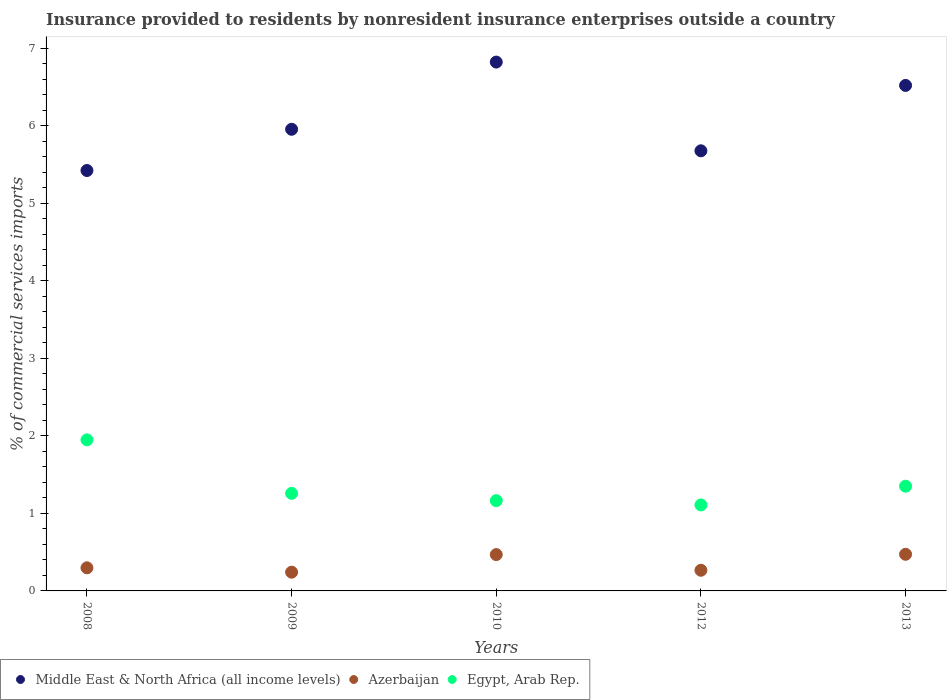Is the number of dotlines equal to the number of legend labels?
Make the answer very short. Yes. What is the Insurance provided to residents in Egypt, Arab Rep. in 2010?
Provide a succinct answer. 1.16. Across all years, what is the maximum Insurance provided to residents in Middle East & North Africa (all income levels)?
Provide a short and direct response. 6.82. Across all years, what is the minimum Insurance provided to residents in Middle East & North Africa (all income levels)?
Your response must be concise. 5.42. What is the total Insurance provided to residents in Middle East & North Africa (all income levels) in the graph?
Offer a very short reply. 30.39. What is the difference between the Insurance provided to residents in Egypt, Arab Rep. in 2009 and that in 2013?
Ensure brevity in your answer.  -0.09. What is the difference between the Insurance provided to residents in Azerbaijan in 2013 and the Insurance provided to residents in Middle East & North Africa (all income levels) in 2012?
Make the answer very short. -5.2. What is the average Insurance provided to residents in Middle East & North Africa (all income levels) per year?
Provide a succinct answer. 6.08. In the year 2012, what is the difference between the Insurance provided to residents in Middle East & North Africa (all income levels) and Insurance provided to residents in Egypt, Arab Rep.?
Provide a succinct answer. 4.57. What is the ratio of the Insurance provided to residents in Middle East & North Africa (all income levels) in 2010 to that in 2013?
Provide a succinct answer. 1.05. What is the difference between the highest and the second highest Insurance provided to residents in Azerbaijan?
Your response must be concise. 0. What is the difference between the highest and the lowest Insurance provided to residents in Middle East & North Africa (all income levels)?
Provide a succinct answer. 1.4. Is the sum of the Insurance provided to residents in Azerbaijan in 2010 and 2013 greater than the maximum Insurance provided to residents in Middle East & North Africa (all income levels) across all years?
Offer a terse response. No. Is it the case that in every year, the sum of the Insurance provided to residents in Azerbaijan and Insurance provided to residents in Egypt, Arab Rep.  is greater than the Insurance provided to residents in Middle East & North Africa (all income levels)?
Offer a very short reply. No. Does the Insurance provided to residents in Egypt, Arab Rep. monotonically increase over the years?
Ensure brevity in your answer.  No. How many dotlines are there?
Ensure brevity in your answer.  3. What is the difference between two consecutive major ticks on the Y-axis?
Your answer should be very brief. 1. Does the graph contain grids?
Keep it short and to the point. No. How are the legend labels stacked?
Your response must be concise. Horizontal. What is the title of the graph?
Your answer should be compact. Insurance provided to residents by nonresident insurance enterprises outside a country. What is the label or title of the X-axis?
Give a very brief answer. Years. What is the label or title of the Y-axis?
Offer a terse response. % of commercial services imports. What is the % of commercial services imports of Middle East & North Africa (all income levels) in 2008?
Your answer should be very brief. 5.42. What is the % of commercial services imports in Azerbaijan in 2008?
Keep it short and to the point. 0.3. What is the % of commercial services imports of Egypt, Arab Rep. in 2008?
Make the answer very short. 1.95. What is the % of commercial services imports in Middle East & North Africa (all income levels) in 2009?
Your answer should be very brief. 5.95. What is the % of commercial services imports of Azerbaijan in 2009?
Offer a terse response. 0.24. What is the % of commercial services imports in Egypt, Arab Rep. in 2009?
Provide a short and direct response. 1.26. What is the % of commercial services imports of Middle East & North Africa (all income levels) in 2010?
Your answer should be compact. 6.82. What is the % of commercial services imports in Azerbaijan in 2010?
Offer a very short reply. 0.47. What is the % of commercial services imports of Egypt, Arab Rep. in 2010?
Provide a succinct answer. 1.16. What is the % of commercial services imports in Middle East & North Africa (all income levels) in 2012?
Offer a very short reply. 5.68. What is the % of commercial services imports in Azerbaijan in 2012?
Provide a short and direct response. 0.27. What is the % of commercial services imports in Egypt, Arab Rep. in 2012?
Provide a short and direct response. 1.11. What is the % of commercial services imports in Middle East & North Africa (all income levels) in 2013?
Your response must be concise. 6.52. What is the % of commercial services imports of Azerbaijan in 2013?
Your response must be concise. 0.47. What is the % of commercial services imports of Egypt, Arab Rep. in 2013?
Make the answer very short. 1.35. Across all years, what is the maximum % of commercial services imports in Middle East & North Africa (all income levels)?
Your response must be concise. 6.82. Across all years, what is the maximum % of commercial services imports in Azerbaijan?
Offer a very short reply. 0.47. Across all years, what is the maximum % of commercial services imports in Egypt, Arab Rep.?
Your answer should be compact. 1.95. Across all years, what is the minimum % of commercial services imports of Middle East & North Africa (all income levels)?
Your answer should be compact. 5.42. Across all years, what is the minimum % of commercial services imports in Azerbaijan?
Your answer should be very brief. 0.24. Across all years, what is the minimum % of commercial services imports of Egypt, Arab Rep.?
Make the answer very short. 1.11. What is the total % of commercial services imports of Middle East & North Africa (all income levels) in the graph?
Give a very brief answer. 30.39. What is the total % of commercial services imports in Azerbaijan in the graph?
Give a very brief answer. 1.75. What is the total % of commercial services imports in Egypt, Arab Rep. in the graph?
Make the answer very short. 6.83. What is the difference between the % of commercial services imports of Middle East & North Africa (all income levels) in 2008 and that in 2009?
Provide a succinct answer. -0.53. What is the difference between the % of commercial services imports of Azerbaijan in 2008 and that in 2009?
Your response must be concise. 0.06. What is the difference between the % of commercial services imports of Egypt, Arab Rep. in 2008 and that in 2009?
Offer a terse response. 0.69. What is the difference between the % of commercial services imports of Middle East & North Africa (all income levels) in 2008 and that in 2010?
Your answer should be very brief. -1.4. What is the difference between the % of commercial services imports in Azerbaijan in 2008 and that in 2010?
Offer a very short reply. -0.17. What is the difference between the % of commercial services imports of Egypt, Arab Rep. in 2008 and that in 2010?
Your answer should be very brief. 0.78. What is the difference between the % of commercial services imports of Middle East & North Africa (all income levels) in 2008 and that in 2012?
Provide a succinct answer. -0.25. What is the difference between the % of commercial services imports in Azerbaijan in 2008 and that in 2012?
Your answer should be very brief. 0.03. What is the difference between the % of commercial services imports of Egypt, Arab Rep. in 2008 and that in 2012?
Your answer should be compact. 0.84. What is the difference between the % of commercial services imports of Middle East & North Africa (all income levels) in 2008 and that in 2013?
Make the answer very short. -1.1. What is the difference between the % of commercial services imports in Azerbaijan in 2008 and that in 2013?
Ensure brevity in your answer.  -0.17. What is the difference between the % of commercial services imports of Egypt, Arab Rep. in 2008 and that in 2013?
Keep it short and to the point. 0.6. What is the difference between the % of commercial services imports in Middle East & North Africa (all income levels) in 2009 and that in 2010?
Your answer should be compact. -0.87. What is the difference between the % of commercial services imports in Azerbaijan in 2009 and that in 2010?
Your answer should be very brief. -0.23. What is the difference between the % of commercial services imports in Egypt, Arab Rep. in 2009 and that in 2010?
Give a very brief answer. 0.09. What is the difference between the % of commercial services imports in Middle East & North Africa (all income levels) in 2009 and that in 2012?
Your response must be concise. 0.28. What is the difference between the % of commercial services imports of Azerbaijan in 2009 and that in 2012?
Your response must be concise. -0.02. What is the difference between the % of commercial services imports in Egypt, Arab Rep. in 2009 and that in 2012?
Provide a succinct answer. 0.15. What is the difference between the % of commercial services imports of Middle East & North Africa (all income levels) in 2009 and that in 2013?
Make the answer very short. -0.57. What is the difference between the % of commercial services imports of Azerbaijan in 2009 and that in 2013?
Offer a terse response. -0.23. What is the difference between the % of commercial services imports in Egypt, Arab Rep. in 2009 and that in 2013?
Make the answer very short. -0.09. What is the difference between the % of commercial services imports in Middle East & North Africa (all income levels) in 2010 and that in 2012?
Ensure brevity in your answer.  1.14. What is the difference between the % of commercial services imports of Azerbaijan in 2010 and that in 2012?
Ensure brevity in your answer.  0.2. What is the difference between the % of commercial services imports of Egypt, Arab Rep. in 2010 and that in 2012?
Make the answer very short. 0.06. What is the difference between the % of commercial services imports in Middle East & North Africa (all income levels) in 2010 and that in 2013?
Provide a succinct answer. 0.3. What is the difference between the % of commercial services imports of Azerbaijan in 2010 and that in 2013?
Your response must be concise. -0. What is the difference between the % of commercial services imports of Egypt, Arab Rep. in 2010 and that in 2013?
Offer a very short reply. -0.19. What is the difference between the % of commercial services imports in Middle East & North Africa (all income levels) in 2012 and that in 2013?
Ensure brevity in your answer.  -0.84. What is the difference between the % of commercial services imports of Azerbaijan in 2012 and that in 2013?
Your response must be concise. -0.21. What is the difference between the % of commercial services imports in Egypt, Arab Rep. in 2012 and that in 2013?
Offer a terse response. -0.24. What is the difference between the % of commercial services imports in Middle East & North Africa (all income levels) in 2008 and the % of commercial services imports in Azerbaijan in 2009?
Offer a very short reply. 5.18. What is the difference between the % of commercial services imports of Middle East & North Africa (all income levels) in 2008 and the % of commercial services imports of Egypt, Arab Rep. in 2009?
Make the answer very short. 4.16. What is the difference between the % of commercial services imports in Azerbaijan in 2008 and the % of commercial services imports in Egypt, Arab Rep. in 2009?
Offer a terse response. -0.96. What is the difference between the % of commercial services imports in Middle East & North Africa (all income levels) in 2008 and the % of commercial services imports in Azerbaijan in 2010?
Your answer should be very brief. 4.95. What is the difference between the % of commercial services imports in Middle East & North Africa (all income levels) in 2008 and the % of commercial services imports in Egypt, Arab Rep. in 2010?
Provide a short and direct response. 4.26. What is the difference between the % of commercial services imports of Azerbaijan in 2008 and the % of commercial services imports of Egypt, Arab Rep. in 2010?
Your answer should be very brief. -0.87. What is the difference between the % of commercial services imports of Middle East & North Africa (all income levels) in 2008 and the % of commercial services imports of Azerbaijan in 2012?
Offer a very short reply. 5.15. What is the difference between the % of commercial services imports of Middle East & North Africa (all income levels) in 2008 and the % of commercial services imports of Egypt, Arab Rep. in 2012?
Offer a terse response. 4.31. What is the difference between the % of commercial services imports in Azerbaijan in 2008 and the % of commercial services imports in Egypt, Arab Rep. in 2012?
Give a very brief answer. -0.81. What is the difference between the % of commercial services imports of Middle East & North Africa (all income levels) in 2008 and the % of commercial services imports of Azerbaijan in 2013?
Give a very brief answer. 4.95. What is the difference between the % of commercial services imports in Middle East & North Africa (all income levels) in 2008 and the % of commercial services imports in Egypt, Arab Rep. in 2013?
Ensure brevity in your answer.  4.07. What is the difference between the % of commercial services imports of Azerbaijan in 2008 and the % of commercial services imports of Egypt, Arab Rep. in 2013?
Offer a terse response. -1.05. What is the difference between the % of commercial services imports in Middle East & North Africa (all income levels) in 2009 and the % of commercial services imports in Azerbaijan in 2010?
Ensure brevity in your answer.  5.48. What is the difference between the % of commercial services imports of Middle East & North Africa (all income levels) in 2009 and the % of commercial services imports of Egypt, Arab Rep. in 2010?
Ensure brevity in your answer.  4.79. What is the difference between the % of commercial services imports in Azerbaijan in 2009 and the % of commercial services imports in Egypt, Arab Rep. in 2010?
Ensure brevity in your answer.  -0.92. What is the difference between the % of commercial services imports of Middle East & North Africa (all income levels) in 2009 and the % of commercial services imports of Azerbaijan in 2012?
Offer a terse response. 5.69. What is the difference between the % of commercial services imports in Middle East & North Africa (all income levels) in 2009 and the % of commercial services imports in Egypt, Arab Rep. in 2012?
Offer a very short reply. 4.84. What is the difference between the % of commercial services imports in Azerbaijan in 2009 and the % of commercial services imports in Egypt, Arab Rep. in 2012?
Make the answer very short. -0.87. What is the difference between the % of commercial services imports of Middle East & North Africa (all income levels) in 2009 and the % of commercial services imports of Azerbaijan in 2013?
Give a very brief answer. 5.48. What is the difference between the % of commercial services imports in Middle East & North Africa (all income levels) in 2009 and the % of commercial services imports in Egypt, Arab Rep. in 2013?
Provide a short and direct response. 4.6. What is the difference between the % of commercial services imports of Azerbaijan in 2009 and the % of commercial services imports of Egypt, Arab Rep. in 2013?
Your response must be concise. -1.11. What is the difference between the % of commercial services imports of Middle East & North Africa (all income levels) in 2010 and the % of commercial services imports of Azerbaijan in 2012?
Provide a short and direct response. 6.55. What is the difference between the % of commercial services imports in Middle East & North Africa (all income levels) in 2010 and the % of commercial services imports in Egypt, Arab Rep. in 2012?
Provide a short and direct response. 5.71. What is the difference between the % of commercial services imports of Azerbaijan in 2010 and the % of commercial services imports of Egypt, Arab Rep. in 2012?
Provide a short and direct response. -0.64. What is the difference between the % of commercial services imports in Middle East & North Africa (all income levels) in 2010 and the % of commercial services imports in Azerbaijan in 2013?
Offer a terse response. 6.35. What is the difference between the % of commercial services imports in Middle East & North Africa (all income levels) in 2010 and the % of commercial services imports in Egypt, Arab Rep. in 2013?
Offer a very short reply. 5.47. What is the difference between the % of commercial services imports of Azerbaijan in 2010 and the % of commercial services imports of Egypt, Arab Rep. in 2013?
Ensure brevity in your answer.  -0.88. What is the difference between the % of commercial services imports in Middle East & North Africa (all income levels) in 2012 and the % of commercial services imports in Azerbaijan in 2013?
Your answer should be very brief. 5.2. What is the difference between the % of commercial services imports in Middle East & North Africa (all income levels) in 2012 and the % of commercial services imports in Egypt, Arab Rep. in 2013?
Keep it short and to the point. 4.32. What is the difference between the % of commercial services imports of Azerbaijan in 2012 and the % of commercial services imports of Egypt, Arab Rep. in 2013?
Your response must be concise. -1.08. What is the average % of commercial services imports in Middle East & North Africa (all income levels) per year?
Your response must be concise. 6.08. What is the average % of commercial services imports in Azerbaijan per year?
Your answer should be compact. 0.35. What is the average % of commercial services imports in Egypt, Arab Rep. per year?
Provide a short and direct response. 1.37. In the year 2008, what is the difference between the % of commercial services imports in Middle East & North Africa (all income levels) and % of commercial services imports in Azerbaijan?
Provide a short and direct response. 5.12. In the year 2008, what is the difference between the % of commercial services imports in Middle East & North Africa (all income levels) and % of commercial services imports in Egypt, Arab Rep.?
Keep it short and to the point. 3.47. In the year 2008, what is the difference between the % of commercial services imports of Azerbaijan and % of commercial services imports of Egypt, Arab Rep.?
Your response must be concise. -1.65. In the year 2009, what is the difference between the % of commercial services imports of Middle East & North Africa (all income levels) and % of commercial services imports of Azerbaijan?
Your response must be concise. 5.71. In the year 2009, what is the difference between the % of commercial services imports of Middle East & North Africa (all income levels) and % of commercial services imports of Egypt, Arab Rep.?
Give a very brief answer. 4.69. In the year 2009, what is the difference between the % of commercial services imports in Azerbaijan and % of commercial services imports in Egypt, Arab Rep.?
Offer a terse response. -1.02. In the year 2010, what is the difference between the % of commercial services imports in Middle East & North Africa (all income levels) and % of commercial services imports in Azerbaijan?
Provide a succinct answer. 6.35. In the year 2010, what is the difference between the % of commercial services imports of Middle East & North Africa (all income levels) and % of commercial services imports of Egypt, Arab Rep.?
Your answer should be compact. 5.66. In the year 2010, what is the difference between the % of commercial services imports in Azerbaijan and % of commercial services imports in Egypt, Arab Rep.?
Offer a very short reply. -0.7. In the year 2012, what is the difference between the % of commercial services imports in Middle East & North Africa (all income levels) and % of commercial services imports in Azerbaijan?
Your answer should be very brief. 5.41. In the year 2012, what is the difference between the % of commercial services imports of Middle East & North Africa (all income levels) and % of commercial services imports of Egypt, Arab Rep.?
Provide a succinct answer. 4.57. In the year 2012, what is the difference between the % of commercial services imports in Azerbaijan and % of commercial services imports in Egypt, Arab Rep.?
Offer a very short reply. -0.84. In the year 2013, what is the difference between the % of commercial services imports of Middle East & North Africa (all income levels) and % of commercial services imports of Azerbaijan?
Keep it short and to the point. 6.05. In the year 2013, what is the difference between the % of commercial services imports of Middle East & North Africa (all income levels) and % of commercial services imports of Egypt, Arab Rep.?
Provide a succinct answer. 5.17. In the year 2013, what is the difference between the % of commercial services imports in Azerbaijan and % of commercial services imports in Egypt, Arab Rep.?
Offer a terse response. -0.88. What is the ratio of the % of commercial services imports in Middle East & North Africa (all income levels) in 2008 to that in 2009?
Give a very brief answer. 0.91. What is the ratio of the % of commercial services imports of Azerbaijan in 2008 to that in 2009?
Provide a succinct answer. 1.23. What is the ratio of the % of commercial services imports of Egypt, Arab Rep. in 2008 to that in 2009?
Offer a terse response. 1.55. What is the ratio of the % of commercial services imports of Middle East & North Africa (all income levels) in 2008 to that in 2010?
Your response must be concise. 0.8. What is the ratio of the % of commercial services imports of Azerbaijan in 2008 to that in 2010?
Your answer should be very brief. 0.64. What is the ratio of the % of commercial services imports in Egypt, Arab Rep. in 2008 to that in 2010?
Your answer should be compact. 1.67. What is the ratio of the % of commercial services imports in Middle East & North Africa (all income levels) in 2008 to that in 2012?
Give a very brief answer. 0.96. What is the ratio of the % of commercial services imports in Azerbaijan in 2008 to that in 2012?
Ensure brevity in your answer.  1.12. What is the ratio of the % of commercial services imports of Egypt, Arab Rep. in 2008 to that in 2012?
Give a very brief answer. 1.76. What is the ratio of the % of commercial services imports of Middle East & North Africa (all income levels) in 2008 to that in 2013?
Your response must be concise. 0.83. What is the ratio of the % of commercial services imports of Azerbaijan in 2008 to that in 2013?
Your response must be concise. 0.63. What is the ratio of the % of commercial services imports in Egypt, Arab Rep. in 2008 to that in 2013?
Provide a short and direct response. 1.44. What is the ratio of the % of commercial services imports of Middle East & North Africa (all income levels) in 2009 to that in 2010?
Give a very brief answer. 0.87. What is the ratio of the % of commercial services imports of Azerbaijan in 2009 to that in 2010?
Your answer should be compact. 0.52. What is the ratio of the % of commercial services imports of Egypt, Arab Rep. in 2009 to that in 2010?
Give a very brief answer. 1.08. What is the ratio of the % of commercial services imports of Middle East & North Africa (all income levels) in 2009 to that in 2012?
Ensure brevity in your answer.  1.05. What is the ratio of the % of commercial services imports of Azerbaijan in 2009 to that in 2012?
Provide a succinct answer. 0.91. What is the ratio of the % of commercial services imports in Egypt, Arab Rep. in 2009 to that in 2012?
Offer a very short reply. 1.14. What is the ratio of the % of commercial services imports of Middle East & North Africa (all income levels) in 2009 to that in 2013?
Your answer should be compact. 0.91. What is the ratio of the % of commercial services imports of Azerbaijan in 2009 to that in 2013?
Offer a terse response. 0.51. What is the ratio of the % of commercial services imports in Egypt, Arab Rep. in 2009 to that in 2013?
Keep it short and to the point. 0.93. What is the ratio of the % of commercial services imports of Middle East & North Africa (all income levels) in 2010 to that in 2012?
Offer a very short reply. 1.2. What is the ratio of the % of commercial services imports of Azerbaijan in 2010 to that in 2012?
Provide a short and direct response. 1.76. What is the ratio of the % of commercial services imports in Egypt, Arab Rep. in 2010 to that in 2012?
Your response must be concise. 1.05. What is the ratio of the % of commercial services imports of Middle East & North Africa (all income levels) in 2010 to that in 2013?
Ensure brevity in your answer.  1.05. What is the ratio of the % of commercial services imports of Egypt, Arab Rep. in 2010 to that in 2013?
Offer a terse response. 0.86. What is the ratio of the % of commercial services imports in Middle East & North Africa (all income levels) in 2012 to that in 2013?
Your response must be concise. 0.87. What is the ratio of the % of commercial services imports in Azerbaijan in 2012 to that in 2013?
Your answer should be compact. 0.56. What is the ratio of the % of commercial services imports in Egypt, Arab Rep. in 2012 to that in 2013?
Your answer should be very brief. 0.82. What is the difference between the highest and the second highest % of commercial services imports of Middle East & North Africa (all income levels)?
Your answer should be compact. 0.3. What is the difference between the highest and the second highest % of commercial services imports of Azerbaijan?
Ensure brevity in your answer.  0. What is the difference between the highest and the second highest % of commercial services imports of Egypt, Arab Rep.?
Offer a very short reply. 0.6. What is the difference between the highest and the lowest % of commercial services imports in Middle East & North Africa (all income levels)?
Offer a very short reply. 1.4. What is the difference between the highest and the lowest % of commercial services imports of Azerbaijan?
Your answer should be compact. 0.23. What is the difference between the highest and the lowest % of commercial services imports in Egypt, Arab Rep.?
Provide a succinct answer. 0.84. 